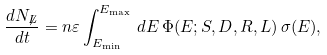<formula> <loc_0><loc_0><loc_500><loc_500>\frac { d N _ { \not L } } { d t } = n \varepsilon \int _ { E _ { \min } } ^ { E _ { \max } } \, d E \, \Phi ( E ; S , D , R , L ) \, \sigma ( E ) ,</formula> 